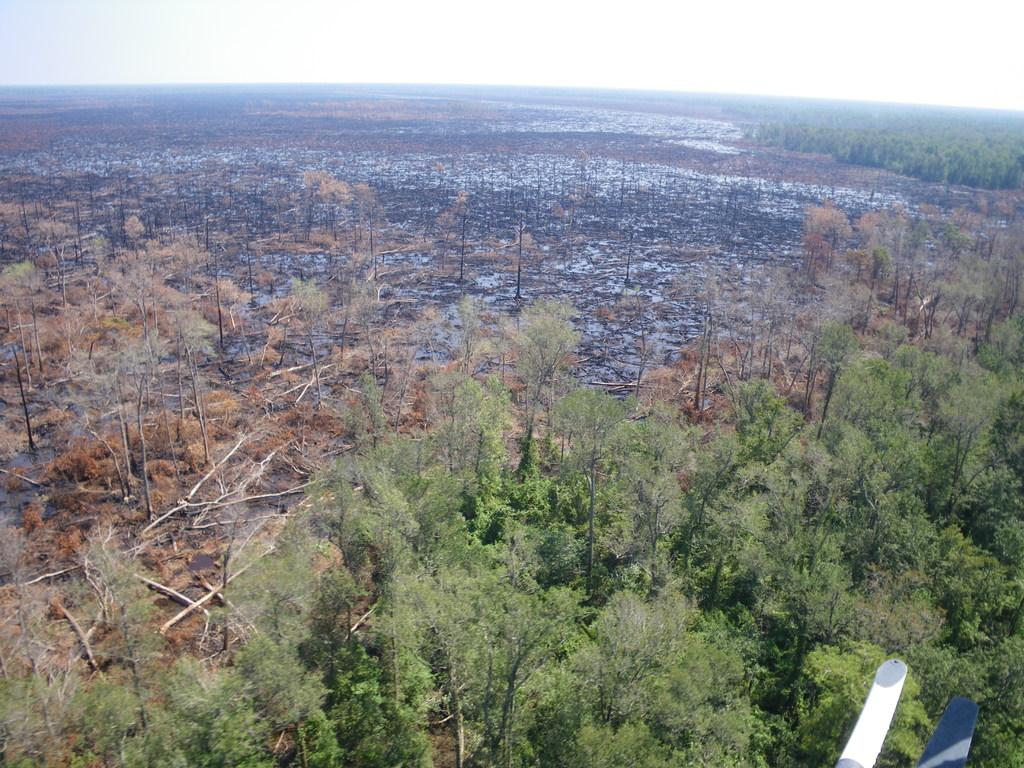What is the main feature of the image? The main feature of the image is the many trees. What is the condition of the trees at the back? The trees appear to be burnt at the back. What can be seen in the sky in the image? The sky is visible in the image. How many parts of the cattle can be seen in the image? There are no cattle present in the image, so it is not possible to determine how many parts might be visible. 